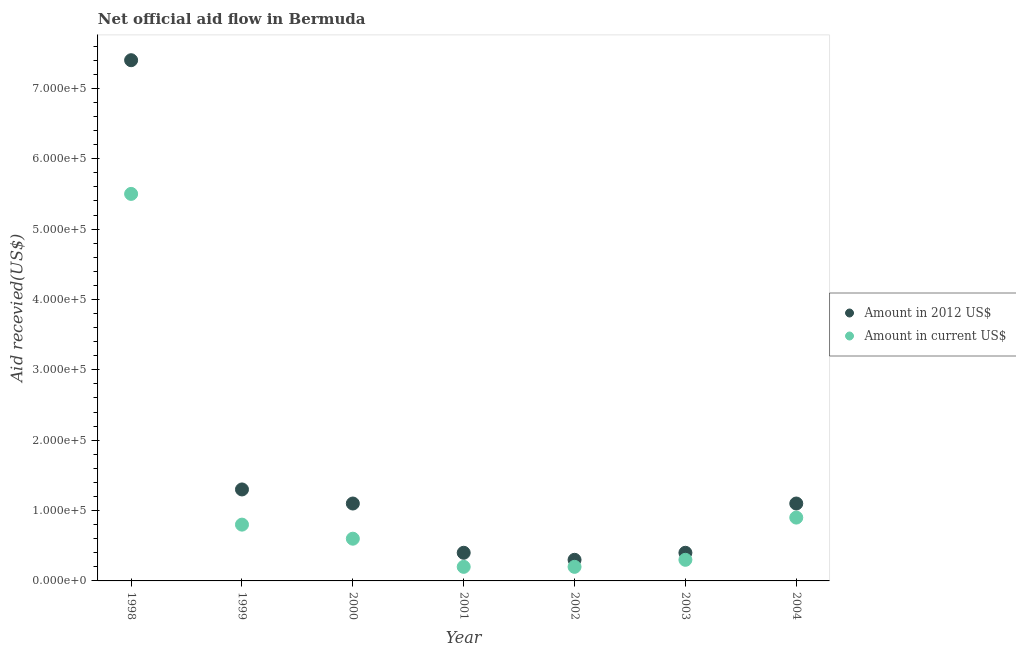Is the number of dotlines equal to the number of legend labels?
Your answer should be very brief. Yes. What is the amount of aid received(expressed in us$) in 2004?
Your response must be concise. 9.00e+04. Across all years, what is the maximum amount of aid received(expressed in us$)?
Keep it short and to the point. 5.50e+05. Across all years, what is the minimum amount of aid received(expressed in 2012 us$)?
Offer a very short reply. 3.00e+04. What is the total amount of aid received(expressed in us$) in the graph?
Provide a succinct answer. 8.50e+05. What is the difference between the amount of aid received(expressed in 2012 us$) in 2003 and that in 2004?
Offer a very short reply. -7.00e+04. What is the difference between the amount of aid received(expressed in 2012 us$) in 2001 and the amount of aid received(expressed in us$) in 2000?
Your answer should be very brief. -2.00e+04. What is the average amount of aid received(expressed in 2012 us$) per year?
Ensure brevity in your answer.  1.71e+05. In the year 2001, what is the difference between the amount of aid received(expressed in 2012 us$) and amount of aid received(expressed in us$)?
Provide a succinct answer. 2.00e+04. In how many years, is the amount of aid received(expressed in 2012 us$) greater than 380000 US$?
Your answer should be very brief. 1. Is the amount of aid received(expressed in us$) in 1998 less than that in 2000?
Provide a short and direct response. No. What is the difference between the highest and the lowest amount of aid received(expressed in us$)?
Your answer should be compact. 5.30e+05. Is the sum of the amount of aid received(expressed in us$) in 2003 and 2004 greater than the maximum amount of aid received(expressed in 2012 us$) across all years?
Your answer should be very brief. No. Does the amount of aid received(expressed in 2012 us$) monotonically increase over the years?
Ensure brevity in your answer.  No. Is the amount of aid received(expressed in 2012 us$) strictly less than the amount of aid received(expressed in us$) over the years?
Your answer should be very brief. No. How many years are there in the graph?
Your answer should be compact. 7. Are the values on the major ticks of Y-axis written in scientific E-notation?
Keep it short and to the point. Yes. Where does the legend appear in the graph?
Give a very brief answer. Center right. How many legend labels are there?
Your answer should be very brief. 2. How are the legend labels stacked?
Ensure brevity in your answer.  Vertical. What is the title of the graph?
Make the answer very short. Net official aid flow in Bermuda. What is the label or title of the X-axis?
Keep it short and to the point. Year. What is the label or title of the Y-axis?
Offer a very short reply. Aid recevied(US$). What is the Aid recevied(US$) of Amount in 2012 US$ in 1998?
Provide a succinct answer. 7.40e+05. What is the Aid recevied(US$) in Amount in 2012 US$ in 1999?
Keep it short and to the point. 1.30e+05. What is the Aid recevied(US$) of Amount in 2012 US$ in 2000?
Ensure brevity in your answer.  1.10e+05. What is the Aid recevied(US$) in Amount in current US$ in 2001?
Make the answer very short. 2.00e+04. What is the Aid recevied(US$) of Amount in current US$ in 2003?
Ensure brevity in your answer.  3.00e+04. Across all years, what is the maximum Aid recevied(US$) in Amount in 2012 US$?
Your response must be concise. 7.40e+05. Across all years, what is the maximum Aid recevied(US$) of Amount in current US$?
Ensure brevity in your answer.  5.50e+05. Across all years, what is the minimum Aid recevied(US$) in Amount in current US$?
Offer a terse response. 2.00e+04. What is the total Aid recevied(US$) of Amount in 2012 US$ in the graph?
Your answer should be very brief. 1.20e+06. What is the total Aid recevied(US$) of Amount in current US$ in the graph?
Provide a succinct answer. 8.50e+05. What is the difference between the Aid recevied(US$) of Amount in current US$ in 1998 and that in 1999?
Ensure brevity in your answer.  4.70e+05. What is the difference between the Aid recevied(US$) of Amount in 2012 US$ in 1998 and that in 2000?
Your answer should be very brief. 6.30e+05. What is the difference between the Aid recevied(US$) of Amount in current US$ in 1998 and that in 2000?
Your answer should be very brief. 4.90e+05. What is the difference between the Aid recevied(US$) in Amount in 2012 US$ in 1998 and that in 2001?
Provide a succinct answer. 7.00e+05. What is the difference between the Aid recevied(US$) of Amount in current US$ in 1998 and that in 2001?
Your response must be concise. 5.30e+05. What is the difference between the Aid recevied(US$) in Amount in 2012 US$ in 1998 and that in 2002?
Offer a terse response. 7.10e+05. What is the difference between the Aid recevied(US$) of Amount in current US$ in 1998 and that in 2002?
Provide a succinct answer. 5.30e+05. What is the difference between the Aid recevied(US$) in Amount in current US$ in 1998 and that in 2003?
Provide a short and direct response. 5.20e+05. What is the difference between the Aid recevied(US$) of Amount in 2012 US$ in 1998 and that in 2004?
Offer a terse response. 6.30e+05. What is the difference between the Aid recevied(US$) of Amount in current US$ in 1999 and that in 2000?
Provide a succinct answer. 2.00e+04. What is the difference between the Aid recevied(US$) in Amount in 2012 US$ in 1999 and that in 2001?
Ensure brevity in your answer.  9.00e+04. What is the difference between the Aid recevied(US$) in Amount in current US$ in 1999 and that in 2001?
Ensure brevity in your answer.  6.00e+04. What is the difference between the Aid recevied(US$) in Amount in current US$ in 1999 and that in 2002?
Offer a very short reply. 6.00e+04. What is the difference between the Aid recevied(US$) of Amount in 2012 US$ in 1999 and that in 2003?
Your answer should be very brief. 9.00e+04. What is the difference between the Aid recevied(US$) in Amount in current US$ in 1999 and that in 2003?
Provide a short and direct response. 5.00e+04. What is the difference between the Aid recevied(US$) in Amount in 2012 US$ in 1999 and that in 2004?
Provide a succinct answer. 2.00e+04. What is the difference between the Aid recevied(US$) in Amount in current US$ in 1999 and that in 2004?
Give a very brief answer. -10000. What is the difference between the Aid recevied(US$) of Amount in current US$ in 2000 and that in 2002?
Your response must be concise. 4.00e+04. What is the difference between the Aid recevied(US$) of Amount in current US$ in 2000 and that in 2003?
Ensure brevity in your answer.  3.00e+04. What is the difference between the Aid recevied(US$) of Amount in 2012 US$ in 2000 and that in 2004?
Your answer should be compact. 0. What is the difference between the Aid recevied(US$) in Amount in current US$ in 2000 and that in 2004?
Give a very brief answer. -3.00e+04. What is the difference between the Aid recevied(US$) in Amount in 2012 US$ in 2001 and that in 2002?
Make the answer very short. 10000. What is the difference between the Aid recevied(US$) of Amount in current US$ in 2001 and that in 2002?
Ensure brevity in your answer.  0. What is the difference between the Aid recevied(US$) in Amount in 2012 US$ in 2001 and that in 2003?
Offer a very short reply. 0. What is the difference between the Aid recevied(US$) of Amount in current US$ in 2001 and that in 2003?
Your response must be concise. -10000. What is the difference between the Aid recevied(US$) of Amount in 2012 US$ in 2001 and that in 2004?
Provide a short and direct response. -7.00e+04. What is the difference between the Aid recevied(US$) of Amount in current US$ in 2001 and that in 2004?
Ensure brevity in your answer.  -7.00e+04. What is the difference between the Aid recevied(US$) of Amount in 2012 US$ in 2003 and that in 2004?
Give a very brief answer. -7.00e+04. What is the difference between the Aid recevied(US$) in Amount in current US$ in 2003 and that in 2004?
Your answer should be compact. -6.00e+04. What is the difference between the Aid recevied(US$) of Amount in 2012 US$ in 1998 and the Aid recevied(US$) of Amount in current US$ in 2000?
Your answer should be very brief. 6.80e+05. What is the difference between the Aid recevied(US$) in Amount in 2012 US$ in 1998 and the Aid recevied(US$) in Amount in current US$ in 2001?
Keep it short and to the point. 7.20e+05. What is the difference between the Aid recevied(US$) in Amount in 2012 US$ in 1998 and the Aid recevied(US$) in Amount in current US$ in 2002?
Your response must be concise. 7.20e+05. What is the difference between the Aid recevied(US$) of Amount in 2012 US$ in 1998 and the Aid recevied(US$) of Amount in current US$ in 2003?
Your answer should be very brief. 7.10e+05. What is the difference between the Aid recevied(US$) in Amount in 2012 US$ in 1998 and the Aid recevied(US$) in Amount in current US$ in 2004?
Your answer should be compact. 6.50e+05. What is the difference between the Aid recevied(US$) in Amount in 2012 US$ in 1999 and the Aid recevied(US$) in Amount in current US$ in 2000?
Make the answer very short. 7.00e+04. What is the difference between the Aid recevied(US$) of Amount in 2012 US$ in 1999 and the Aid recevied(US$) of Amount in current US$ in 2001?
Offer a terse response. 1.10e+05. What is the difference between the Aid recevied(US$) of Amount in 2012 US$ in 1999 and the Aid recevied(US$) of Amount in current US$ in 2004?
Your answer should be very brief. 4.00e+04. What is the difference between the Aid recevied(US$) in Amount in 2012 US$ in 2000 and the Aid recevied(US$) in Amount in current US$ in 2001?
Keep it short and to the point. 9.00e+04. What is the difference between the Aid recevied(US$) of Amount in 2012 US$ in 2001 and the Aid recevied(US$) of Amount in current US$ in 2004?
Offer a very short reply. -5.00e+04. What is the difference between the Aid recevied(US$) of Amount in 2012 US$ in 2002 and the Aid recevied(US$) of Amount in current US$ in 2003?
Ensure brevity in your answer.  0. What is the difference between the Aid recevied(US$) in Amount in 2012 US$ in 2003 and the Aid recevied(US$) in Amount in current US$ in 2004?
Give a very brief answer. -5.00e+04. What is the average Aid recevied(US$) of Amount in 2012 US$ per year?
Ensure brevity in your answer.  1.71e+05. What is the average Aid recevied(US$) in Amount in current US$ per year?
Provide a succinct answer. 1.21e+05. In the year 1998, what is the difference between the Aid recevied(US$) of Amount in 2012 US$ and Aid recevied(US$) of Amount in current US$?
Make the answer very short. 1.90e+05. In the year 1999, what is the difference between the Aid recevied(US$) in Amount in 2012 US$ and Aid recevied(US$) in Amount in current US$?
Provide a short and direct response. 5.00e+04. In the year 2002, what is the difference between the Aid recevied(US$) of Amount in 2012 US$ and Aid recevied(US$) of Amount in current US$?
Offer a very short reply. 10000. In the year 2003, what is the difference between the Aid recevied(US$) of Amount in 2012 US$ and Aid recevied(US$) of Amount in current US$?
Make the answer very short. 10000. What is the ratio of the Aid recevied(US$) of Amount in 2012 US$ in 1998 to that in 1999?
Give a very brief answer. 5.69. What is the ratio of the Aid recevied(US$) in Amount in current US$ in 1998 to that in 1999?
Your answer should be compact. 6.88. What is the ratio of the Aid recevied(US$) of Amount in 2012 US$ in 1998 to that in 2000?
Provide a short and direct response. 6.73. What is the ratio of the Aid recevied(US$) of Amount in current US$ in 1998 to that in 2000?
Make the answer very short. 9.17. What is the ratio of the Aid recevied(US$) of Amount in 2012 US$ in 1998 to that in 2001?
Provide a short and direct response. 18.5. What is the ratio of the Aid recevied(US$) in Amount in current US$ in 1998 to that in 2001?
Keep it short and to the point. 27.5. What is the ratio of the Aid recevied(US$) in Amount in 2012 US$ in 1998 to that in 2002?
Give a very brief answer. 24.67. What is the ratio of the Aid recevied(US$) of Amount in 2012 US$ in 1998 to that in 2003?
Ensure brevity in your answer.  18.5. What is the ratio of the Aid recevied(US$) of Amount in current US$ in 1998 to that in 2003?
Offer a very short reply. 18.33. What is the ratio of the Aid recevied(US$) in Amount in 2012 US$ in 1998 to that in 2004?
Your response must be concise. 6.73. What is the ratio of the Aid recevied(US$) of Amount in current US$ in 1998 to that in 2004?
Offer a terse response. 6.11. What is the ratio of the Aid recevied(US$) in Amount in 2012 US$ in 1999 to that in 2000?
Offer a terse response. 1.18. What is the ratio of the Aid recevied(US$) in Amount in 2012 US$ in 1999 to that in 2001?
Your answer should be compact. 3.25. What is the ratio of the Aid recevied(US$) in Amount in current US$ in 1999 to that in 2001?
Your response must be concise. 4. What is the ratio of the Aid recevied(US$) in Amount in 2012 US$ in 1999 to that in 2002?
Your response must be concise. 4.33. What is the ratio of the Aid recevied(US$) of Amount in current US$ in 1999 to that in 2003?
Your response must be concise. 2.67. What is the ratio of the Aid recevied(US$) in Amount in 2012 US$ in 1999 to that in 2004?
Make the answer very short. 1.18. What is the ratio of the Aid recevied(US$) of Amount in 2012 US$ in 2000 to that in 2001?
Keep it short and to the point. 2.75. What is the ratio of the Aid recevied(US$) of Amount in 2012 US$ in 2000 to that in 2002?
Your answer should be compact. 3.67. What is the ratio of the Aid recevied(US$) in Amount in 2012 US$ in 2000 to that in 2003?
Your response must be concise. 2.75. What is the ratio of the Aid recevied(US$) of Amount in current US$ in 2000 to that in 2003?
Offer a terse response. 2. What is the ratio of the Aid recevied(US$) of Amount in 2012 US$ in 2001 to that in 2002?
Your answer should be compact. 1.33. What is the ratio of the Aid recevied(US$) in Amount in current US$ in 2001 to that in 2002?
Your answer should be very brief. 1. What is the ratio of the Aid recevied(US$) in Amount in 2012 US$ in 2001 to that in 2003?
Offer a very short reply. 1. What is the ratio of the Aid recevied(US$) in Amount in current US$ in 2001 to that in 2003?
Your response must be concise. 0.67. What is the ratio of the Aid recevied(US$) in Amount in 2012 US$ in 2001 to that in 2004?
Keep it short and to the point. 0.36. What is the ratio of the Aid recevied(US$) in Amount in current US$ in 2001 to that in 2004?
Give a very brief answer. 0.22. What is the ratio of the Aid recevied(US$) in Amount in 2012 US$ in 2002 to that in 2003?
Provide a succinct answer. 0.75. What is the ratio of the Aid recevied(US$) of Amount in 2012 US$ in 2002 to that in 2004?
Provide a succinct answer. 0.27. What is the ratio of the Aid recevied(US$) of Amount in current US$ in 2002 to that in 2004?
Offer a terse response. 0.22. What is the ratio of the Aid recevied(US$) in Amount in 2012 US$ in 2003 to that in 2004?
Provide a succinct answer. 0.36. What is the ratio of the Aid recevied(US$) in Amount in current US$ in 2003 to that in 2004?
Ensure brevity in your answer.  0.33. What is the difference between the highest and the lowest Aid recevied(US$) of Amount in 2012 US$?
Your answer should be compact. 7.10e+05. What is the difference between the highest and the lowest Aid recevied(US$) in Amount in current US$?
Make the answer very short. 5.30e+05. 